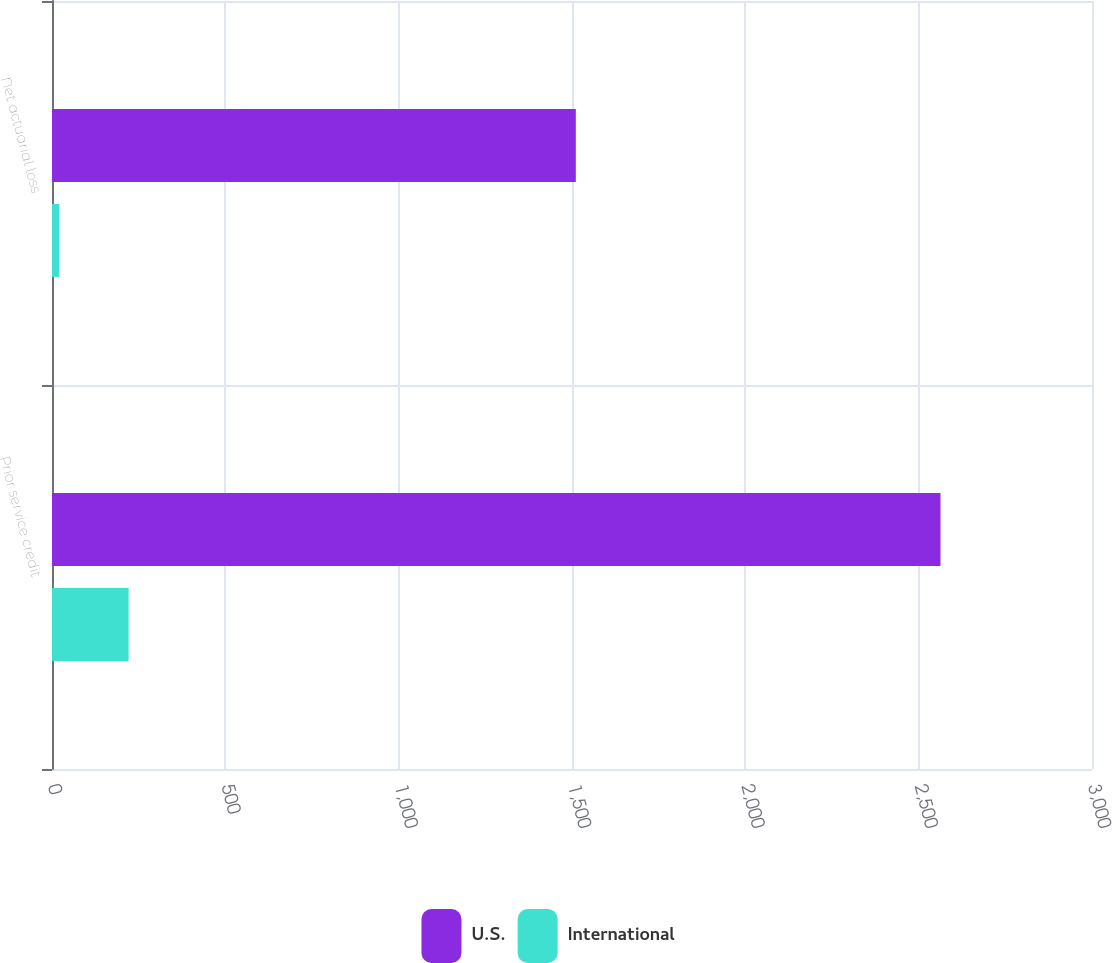<chart> <loc_0><loc_0><loc_500><loc_500><stacked_bar_chart><ecel><fcel>Prior service credit<fcel>Net actuarial loss<nl><fcel>U.S.<fcel>2563<fcel>1511<nl><fcel>International<fcel>221<fcel>21<nl></chart> 